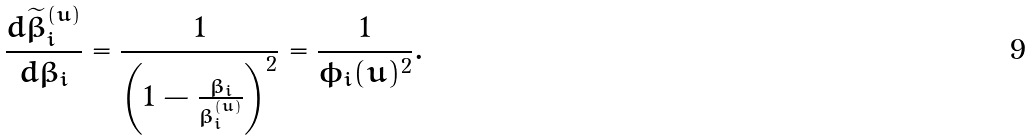<formula> <loc_0><loc_0><loc_500><loc_500>\frac { d \widetilde { \beta } _ { i } ^ { ( u ) } } { d \beta _ { i } } = \frac { 1 } { \left ( 1 - \frac { \beta _ { i } } { \beta _ { i } ^ { ( u ) } } \right ) ^ { 2 } } = \frac { 1 } { \phi _ { i } ( u ) ^ { 2 } } .</formula> 